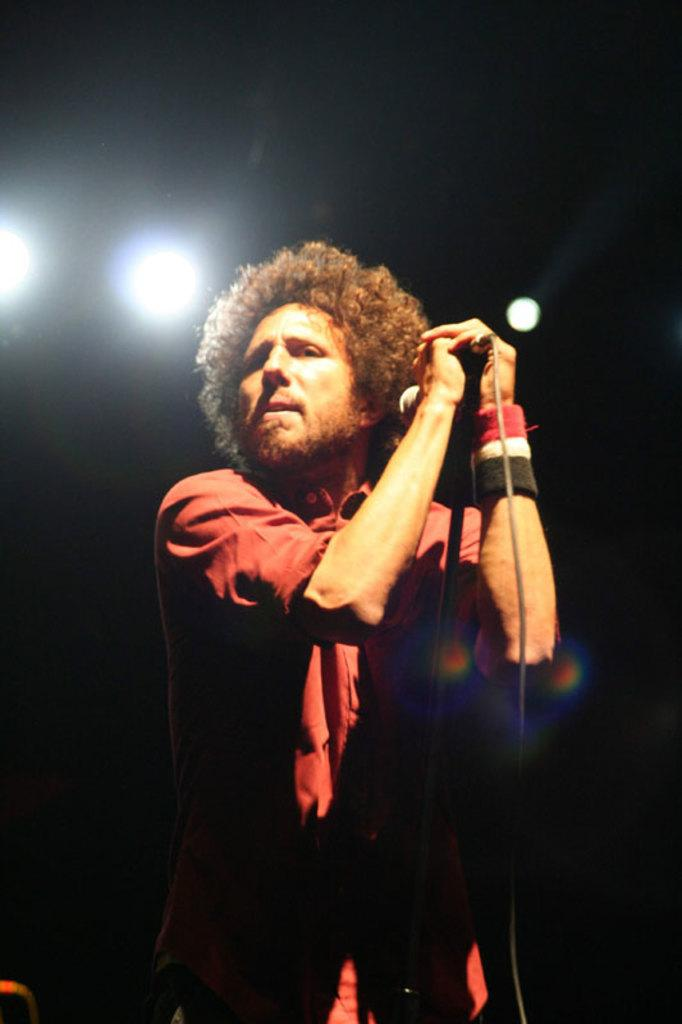What is the main subject of the image? There is a man in the image. What is the man wearing? The man is wearing a red shirt. What is the man doing in the image? The man is standing and holding a microphone in his hands. Can you describe the man's hair? The man has curly hair. What can be seen at the top of the image? There are three lights at the top of the image. What type of bubble is floating near the man's head in the image? There is no bubble present in the image. What color is the orange that the man is holding in the image? There is no orange present in the image. 